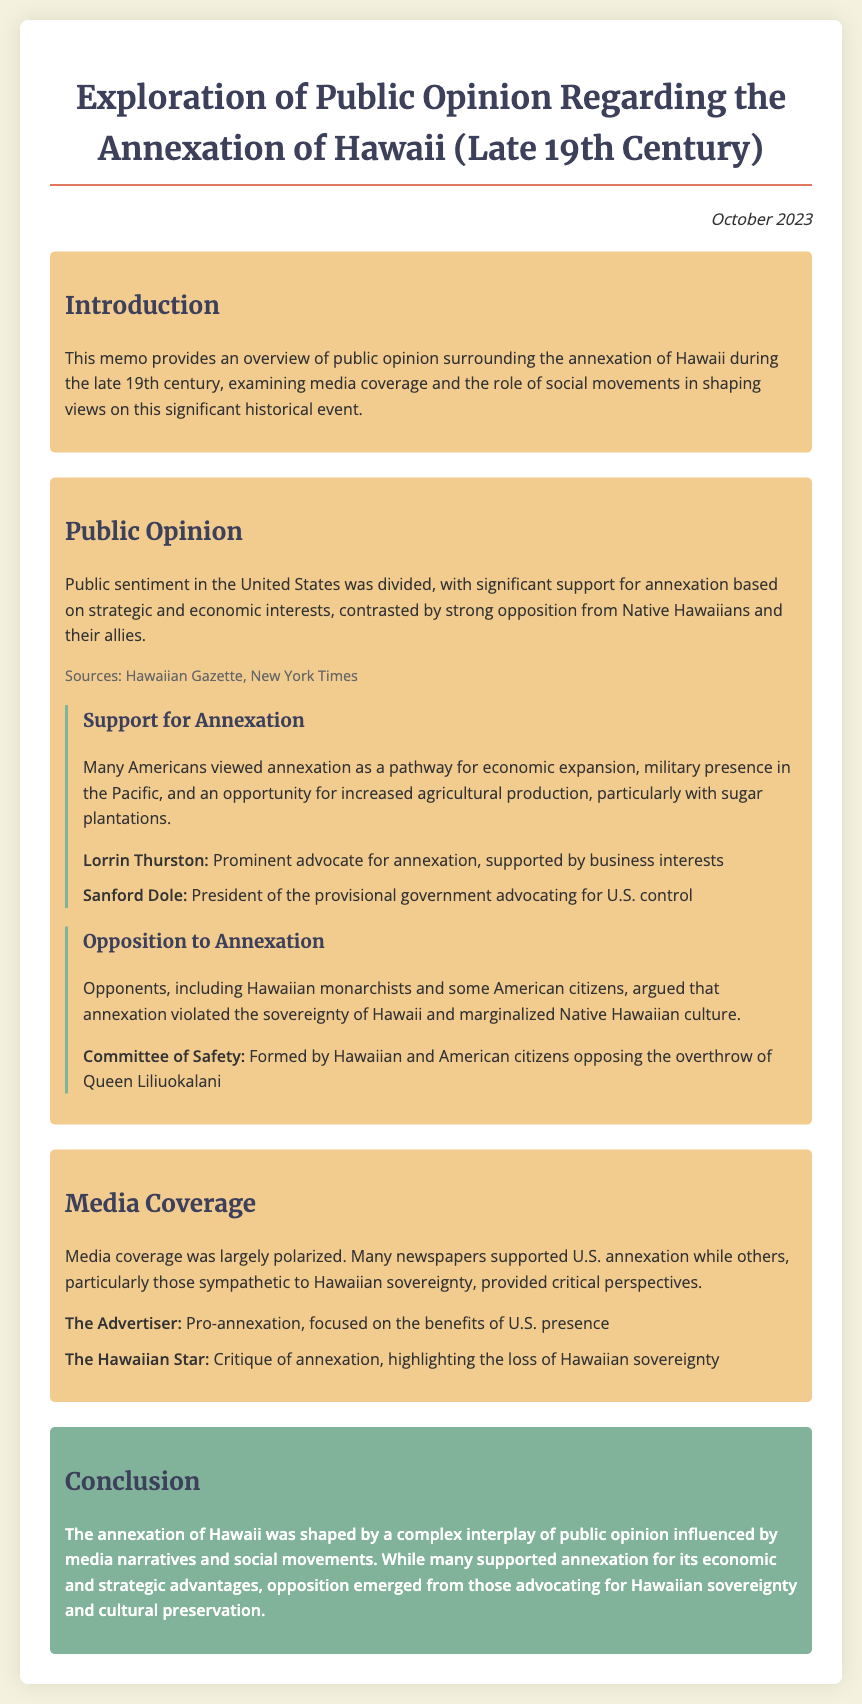What is the title of the memo? The title of the memo is explicitly stated at the top of the document.
Answer: Exploration of Public Opinion Regarding the Annexation of Hawaii (Late 19th Century) When was this memo created? The date is provided in the document's header.
Answer: October 2023 Who was a prominent advocate for annexation? The document names specific individuals advocating for annexation in the support section.
Answer: Lorrin Thurston What role did Sanford Dole hold during the annexation? The document specifies Sanford Dole's title in relation to the provisional government.
Answer: President of the provisional government Which publication critiqued the annexation emphasizing the loss of Hawaiian sovereignty? The memo lists media outlets and their stance on annexation in the media coverage section.
Answer: The Hawaiian Star What was a major concern among the opposition to annexation? The document summarizes key opposition arguments regarding the nature of annexation.
Answer: Sovereignty of Hawaii What economic opportunity was highlighted by supporters for annexation? The section on support for annexation mentions specific economic benefits.
Answer: Increased agricultural production Which social movement formed in opposition to the overthrow of Queen Liliuokalani? The memo names specific groups or committees that opposed annexation.
Answer: Committee of Safety How was media coverage characterized in the memo? The document describes the overall nature of media coverage regarding the annexation.
Answer: Largely polarized 